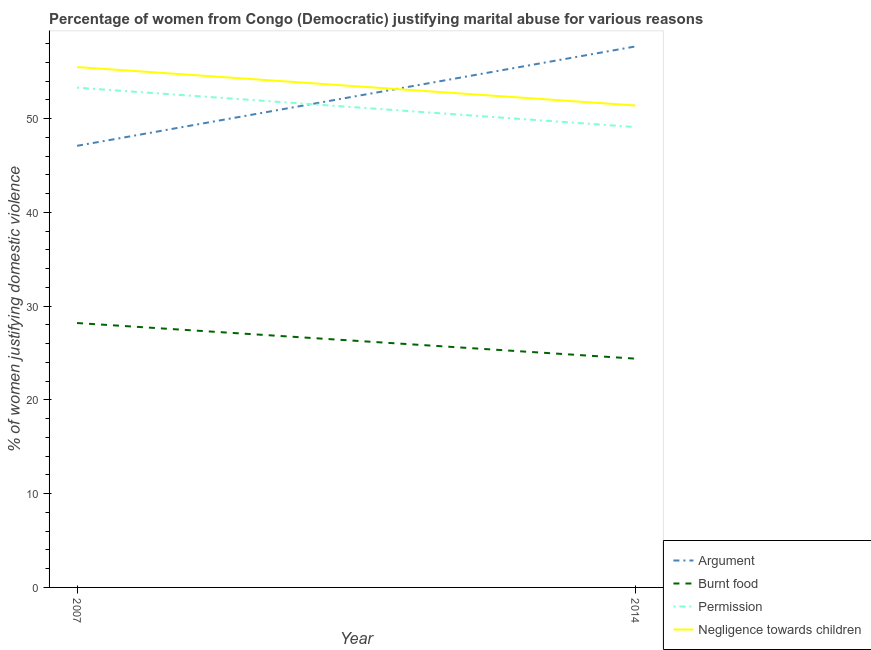How many different coloured lines are there?
Your response must be concise. 4. Is the number of lines equal to the number of legend labels?
Your response must be concise. Yes. What is the percentage of women justifying abuse in the case of an argument in 2007?
Make the answer very short. 47.1. Across all years, what is the maximum percentage of women justifying abuse for showing negligence towards children?
Your response must be concise. 55.5. Across all years, what is the minimum percentage of women justifying abuse in the case of an argument?
Your response must be concise. 47.1. In which year was the percentage of women justifying abuse for going without permission maximum?
Your answer should be compact. 2007. In which year was the percentage of women justifying abuse for burning food minimum?
Your answer should be very brief. 2014. What is the total percentage of women justifying abuse for going without permission in the graph?
Keep it short and to the point. 102.4. What is the difference between the percentage of women justifying abuse for going without permission in 2007 and that in 2014?
Make the answer very short. 4.2. What is the difference between the percentage of women justifying abuse for going without permission in 2014 and the percentage of women justifying abuse for burning food in 2007?
Make the answer very short. 20.9. What is the average percentage of women justifying abuse for burning food per year?
Provide a short and direct response. 26.3. In the year 2014, what is the difference between the percentage of women justifying abuse for burning food and percentage of women justifying abuse in the case of an argument?
Provide a short and direct response. -33.3. What is the ratio of the percentage of women justifying abuse for going without permission in 2007 to that in 2014?
Make the answer very short. 1.09. In how many years, is the percentage of women justifying abuse for showing negligence towards children greater than the average percentage of women justifying abuse for showing negligence towards children taken over all years?
Offer a terse response. 1. Is it the case that in every year, the sum of the percentage of women justifying abuse in the case of an argument and percentage of women justifying abuse for burning food is greater than the percentage of women justifying abuse for going without permission?
Your answer should be very brief. Yes. How many years are there in the graph?
Your answer should be very brief. 2. Does the graph contain any zero values?
Offer a terse response. No. How many legend labels are there?
Provide a short and direct response. 4. How are the legend labels stacked?
Offer a very short reply. Vertical. What is the title of the graph?
Ensure brevity in your answer.  Percentage of women from Congo (Democratic) justifying marital abuse for various reasons. Does "Coal" appear as one of the legend labels in the graph?
Offer a very short reply. No. What is the label or title of the Y-axis?
Your answer should be very brief. % of women justifying domestic violence. What is the % of women justifying domestic violence in Argument in 2007?
Provide a succinct answer. 47.1. What is the % of women justifying domestic violence in Burnt food in 2007?
Your answer should be compact. 28.2. What is the % of women justifying domestic violence of Permission in 2007?
Provide a short and direct response. 53.3. What is the % of women justifying domestic violence of Negligence towards children in 2007?
Your answer should be very brief. 55.5. What is the % of women justifying domestic violence of Argument in 2014?
Your response must be concise. 57.7. What is the % of women justifying domestic violence in Burnt food in 2014?
Your response must be concise. 24.4. What is the % of women justifying domestic violence of Permission in 2014?
Your answer should be compact. 49.1. What is the % of women justifying domestic violence in Negligence towards children in 2014?
Give a very brief answer. 51.4. Across all years, what is the maximum % of women justifying domestic violence in Argument?
Make the answer very short. 57.7. Across all years, what is the maximum % of women justifying domestic violence of Burnt food?
Offer a terse response. 28.2. Across all years, what is the maximum % of women justifying domestic violence in Permission?
Keep it short and to the point. 53.3. Across all years, what is the maximum % of women justifying domestic violence of Negligence towards children?
Keep it short and to the point. 55.5. Across all years, what is the minimum % of women justifying domestic violence in Argument?
Ensure brevity in your answer.  47.1. Across all years, what is the minimum % of women justifying domestic violence in Burnt food?
Provide a succinct answer. 24.4. Across all years, what is the minimum % of women justifying domestic violence of Permission?
Provide a succinct answer. 49.1. Across all years, what is the minimum % of women justifying domestic violence of Negligence towards children?
Provide a short and direct response. 51.4. What is the total % of women justifying domestic violence of Argument in the graph?
Your answer should be very brief. 104.8. What is the total % of women justifying domestic violence in Burnt food in the graph?
Your answer should be very brief. 52.6. What is the total % of women justifying domestic violence of Permission in the graph?
Ensure brevity in your answer.  102.4. What is the total % of women justifying domestic violence in Negligence towards children in the graph?
Give a very brief answer. 106.9. What is the difference between the % of women justifying domestic violence in Burnt food in 2007 and that in 2014?
Provide a succinct answer. 3.8. What is the difference between the % of women justifying domestic violence in Permission in 2007 and that in 2014?
Your answer should be very brief. 4.2. What is the difference between the % of women justifying domestic violence of Negligence towards children in 2007 and that in 2014?
Provide a succinct answer. 4.1. What is the difference between the % of women justifying domestic violence in Argument in 2007 and the % of women justifying domestic violence in Burnt food in 2014?
Your response must be concise. 22.7. What is the difference between the % of women justifying domestic violence in Argument in 2007 and the % of women justifying domestic violence in Permission in 2014?
Provide a succinct answer. -2. What is the difference between the % of women justifying domestic violence of Argument in 2007 and the % of women justifying domestic violence of Negligence towards children in 2014?
Your answer should be compact. -4.3. What is the difference between the % of women justifying domestic violence in Burnt food in 2007 and the % of women justifying domestic violence in Permission in 2014?
Provide a short and direct response. -20.9. What is the difference between the % of women justifying domestic violence in Burnt food in 2007 and the % of women justifying domestic violence in Negligence towards children in 2014?
Give a very brief answer. -23.2. What is the difference between the % of women justifying domestic violence of Permission in 2007 and the % of women justifying domestic violence of Negligence towards children in 2014?
Offer a very short reply. 1.9. What is the average % of women justifying domestic violence of Argument per year?
Offer a terse response. 52.4. What is the average % of women justifying domestic violence in Burnt food per year?
Ensure brevity in your answer.  26.3. What is the average % of women justifying domestic violence in Permission per year?
Give a very brief answer. 51.2. What is the average % of women justifying domestic violence in Negligence towards children per year?
Your answer should be very brief. 53.45. In the year 2007, what is the difference between the % of women justifying domestic violence in Argument and % of women justifying domestic violence in Negligence towards children?
Your answer should be very brief. -8.4. In the year 2007, what is the difference between the % of women justifying domestic violence of Burnt food and % of women justifying domestic violence of Permission?
Your answer should be very brief. -25.1. In the year 2007, what is the difference between the % of women justifying domestic violence of Burnt food and % of women justifying domestic violence of Negligence towards children?
Keep it short and to the point. -27.3. In the year 2007, what is the difference between the % of women justifying domestic violence of Permission and % of women justifying domestic violence of Negligence towards children?
Provide a succinct answer. -2.2. In the year 2014, what is the difference between the % of women justifying domestic violence in Argument and % of women justifying domestic violence in Burnt food?
Ensure brevity in your answer.  33.3. In the year 2014, what is the difference between the % of women justifying domestic violence of Argument and % of women justifying domestic violence of Permission?
Your answer should be very brief. 8.6. In the year 2014, what is the difference between the % of women justifying domestic violence in Burnt food and % of women justifying domestic violence in Permission?
Provide a short and direct response. -24.7. In the year 2014, what is the difference between the % of women justifying domestic violence of Permission and % of women justifying domestic violence of Negligence towards children?
Ensure brevity in your answer.  -2.3. What is the ratio of the % of women justifying domestic violence of Argument in 2007 to that in 2014?
Provide a succinct answer. 0.82. What is the ratio of the % of women justifying domestic violence in Burnt food in 2007 to that in 2014?
Your answer should be compact. 1.16. What is the ratio of the % of women justifying domestic violence of Permission in 2007 to that in 2014?
Your answer should be compact. 1.09. What is the ratio of the % of women justifying domestic violence in Negligence towards children in 2007 to that in 2014?
Give a very brief answer. 1.08. What is the difference between the highest and the second highest % of women justifying domestic violence in Permission?
Provide a short and direct response. 4.2. What is the difference between the highest and the lowest % of women justifying domestic violence of Argument?
Provide a short and direct response. 10.6. What is the difference between the highest and the lowest % of women justifying domestic violence of Negligence towards children?
Provide a short and direct response. 4.1. 